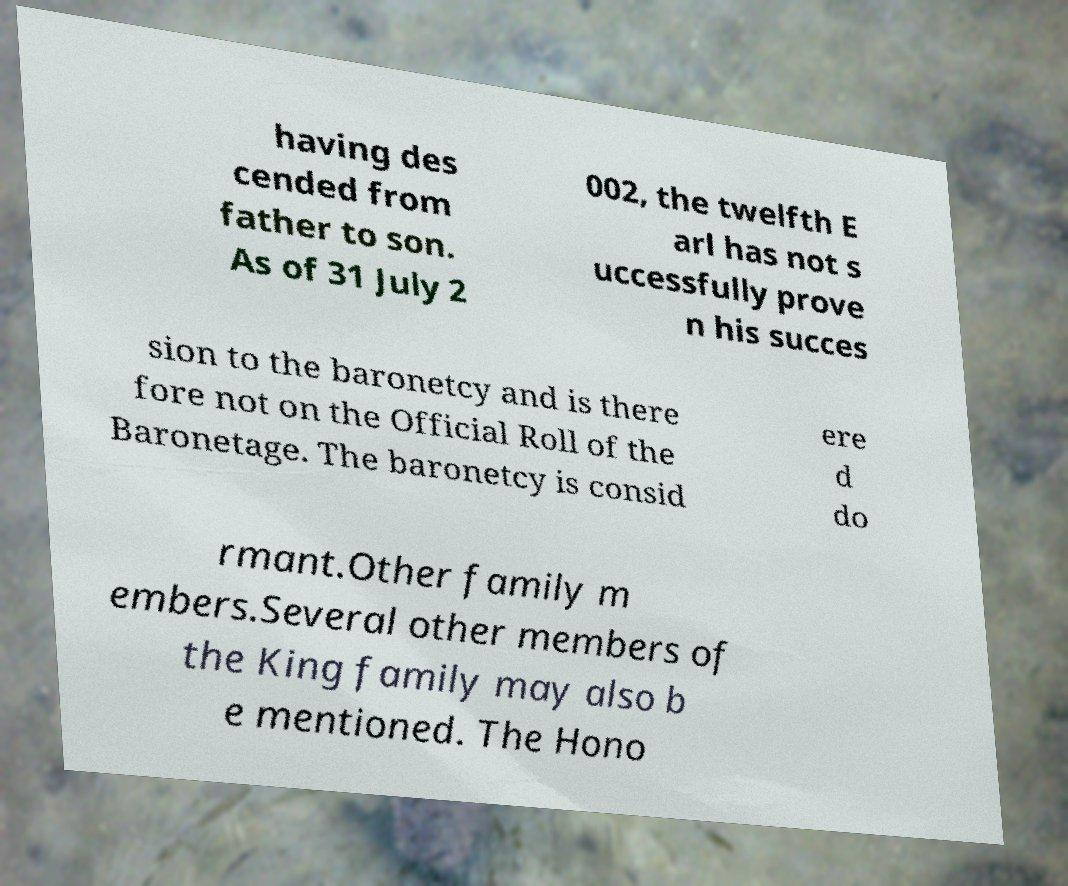For documentation purposes, I need the text within this image transcribed. Could you provide that? having des cended from father to son. As of 31 July 2 002, the twelfth E arl has not s uccessfully prove n his succes sion to the baronetcy and is there fore not on the Official Roll of the Baronetage. The baronetcy is consid ere d do rmant.Other family m embers.Several other members of the King family may also b e mentioned. The Hono 